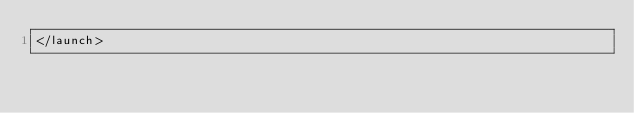<code> <loc_0><loc_0><loc_500><loc_500><_XML_></launch>
</code> 